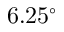<formula> <loc_0><loc_0><loc_500><loc_500>6 . 2 5 ^ { \circ }</formula> 